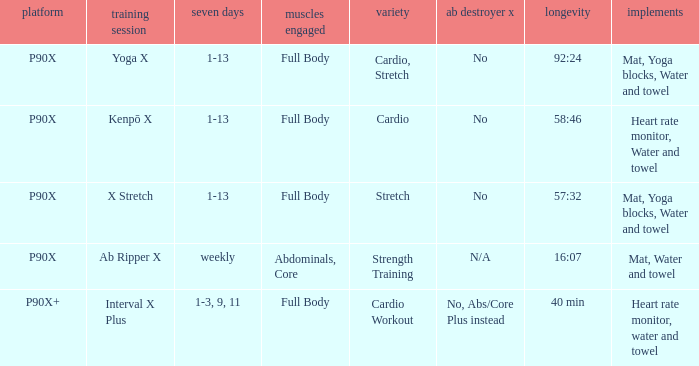What is the week when type is cardio workout? 1-3, 9, 11. 